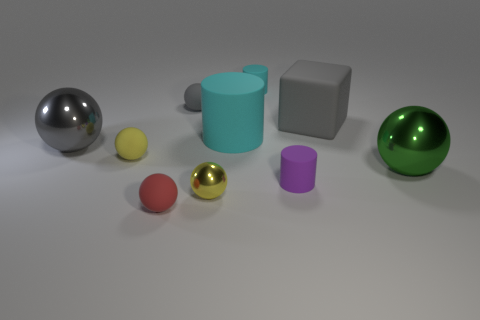Subtract 1 cylinders. How many cylinders are left? 2 Subtract all large green metal balls. How many balls are left? 5 Subtract all yellow spheres. How many spheres are left? 4 Subtract all red balls. Subtract all purple cubes. How many balls are left? 5 Subtract all blocks. How many objects are left? 9 Add 6 large cyan rubber things. How many large cyan rubber things exist? 7 Subtract 0 red blocks. How many objects are left? 10 Subtract all large green metallic cubes. Subtract all small purple matte cylinders. How many objects are left? 9 Add 8 small purple rubber objects. How many small purple rubber objects are left? 9 